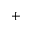Convert formula to latex. <formula><loc_0><loc_0><loc_500><loc_500>^ { + }</formula> 